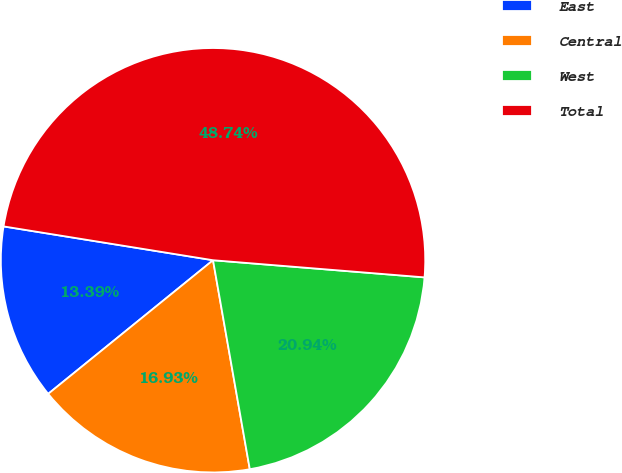Convert chart. <chart><loc_0><loc_0><loc_500><loc_500><pie_chart><fcel>East<fcel>Central<fcel>West<fcel>Total<nl><fcel>13.39%<fcel>16.93%<fcel>20.94%<fcel>48.74%<nl></chart> 